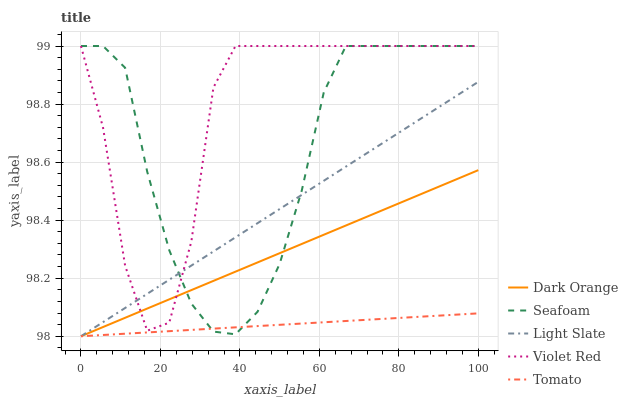Does Tomato have the minimum area under the curve?
Answer yes or no. Yes. Does Violet Red have the maximum area under the curve?
Answer yes or no. Yes. Does Dark Orange have the minimum area under the curve?
Answer yes or no. No. Does Dark Orange have the maximum area under the curve?
Answer yes or no. No. Is Tomato the smoothest?
Answer yes or no. Yes. Is Violet Red the roughest?
Answer yes or no. Yes. Is Dark Orange the smoothest?
Answer yes or no. No. Is Dark Orange the roughest?
Answer yes or no. No. Does Light Slate have the lowest value?
Answer yes or no. Yes. Does Violet Red have the lowest value?
Answer yes or no. No. Does Seafoam have the highest value?
Answer yes or no. Yes. Does Dark Orange have the highest value?
Answer yes or no. No. Is Tomato less than Violet Red?
Answer yes or no. Yes. Is Violet Red greater than Tomato?
Answer yes or no. Yes. Does Tomato intersect Light Slate?
Answer yes or no. Yes. Is Tomato less than Light Slate?
Answer yes or no. No. Is Tomato greater than Light Slate?
Answer yes or no. No. Does Tomato intersect Violet Red?
Answer yes or no. No. 